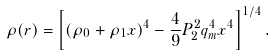Convert formula to latex. <formula><loc_0><loc_0><loc_500><loc_500>\rho ( r ) = \left [ ( \rho _ { 0 } + \rho _ { 1 } x ) ^ { 4 } - \frac { 4 } { 9 } P _ { 2 } ^ { 2 } q _ { m } ^ { 4 } x ^ { 4 } \right ] ^ { 1 / 4 } .</formula> 